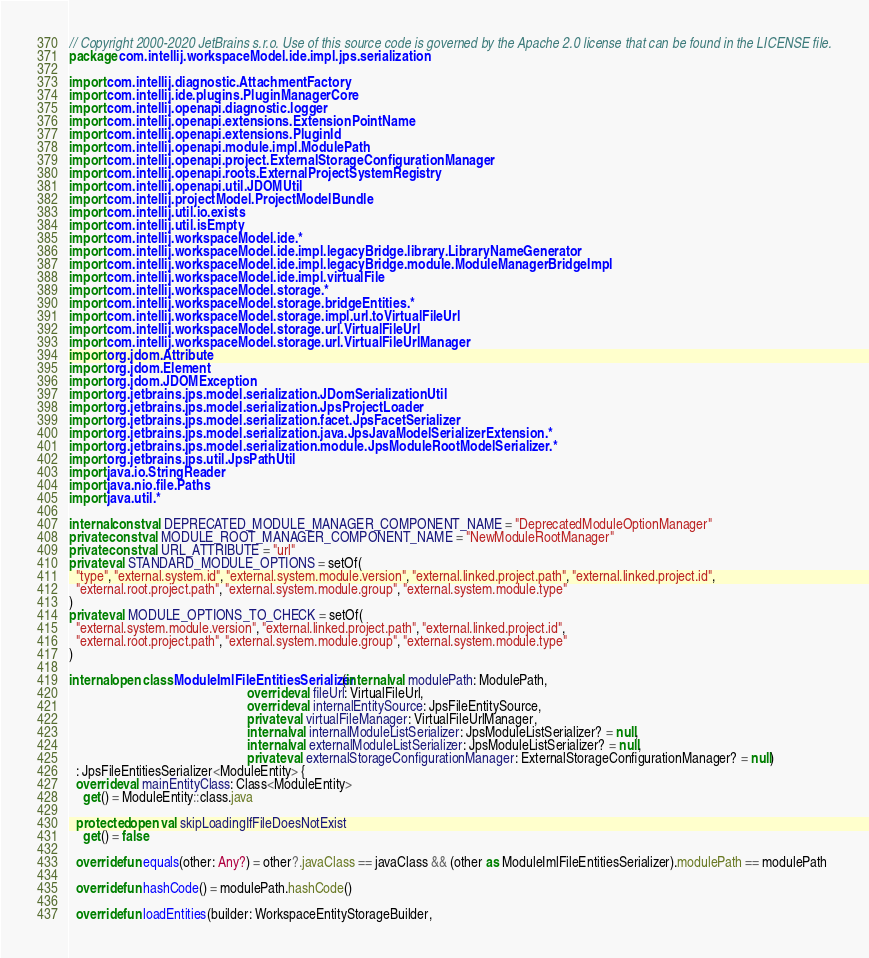Convert code to text. <code><loc_0><loc_0><loc_500><loc_500><_Kotlin_>// Copyright 2000-2020 JetBrains s.r.o. Use of this source code is governed by the Apache 2.0 license that can be found in the LICENSE file.
package com.intellij.workspaceModel.ide.impl.jps.serialization

import com.intellij.diagnostic.AttachmentFactory
import com.intellij.ide.plugins.PluginManagerCore
import com.intellij.openapi.diagnostic.logger
import com.intellij.openapi.extensions.ExtensionPointName
import com.intellij.openapi.extensions.PluginId
import com.intellij.openapi.module.impl.ModulePath
import com.intellij.openapi.project.ExternalStorageConfigurationManager
import com.intellij.openapi.roots.ExternalProjectSystemRegistry
import com.intellij.openapi.util.JDOMUtil
import com.intellij.projectModel.ProjectModelBundle
import com.intellij.util.io.exists
import com.intellij.util.isEmpty
import com.intellij.workspaceModel.ide.*
import com.intellij.workspaceModel.ide.impl.legacyBridge.library.LibraryNameGenerator
import com.intellij.workspaceModel.ide.impl.legacyBridge.module.ModuleManagerBridgeImpl
import com.intellij.workspaceModel.ide.impl.virtualFile
import com.intellij.workspaceModel.storage.*
import com.intellij.workspaceModel.storage.bridgeEntities.*
import com.intellij.workspaceModel.storage.impl.url.toVirtualFileUrl
import com.intellij.workspaceModel.storage.url.VirtualFileUrl
import com.intellij.workspaceModel.storage.url.VirtualFileUrlManager
import org.jdom.Attribute
import org.jdom.Element
import org.jdom.JDOMException
import org.jetbrains.jps.model.serialization.JDomSerializationUtil
import org.jetbrains.jps.model.serialization.JpsProjectLoader
import org.jetbrains.jps.model.serialization.facet.JpsFacetSerializer
import org.jetbrains.jps.model.serialization.java.JpsJavaModelSerializerExtension.*
import org.jetbrains.jps.model.serialization.module.JpsModuleRootModelSerializer.*
import org.jetbrains.jps.util.JpsPathUtil
import java.io.StringReader
import java.nio.file.Paths
import java.util.*

internal const val DEPRECATED_MODULE_MANAGER_COMPONENT_NAME = "DeprecatedModuleOptionManager"
private const val MODULE_ROOT_MANAGER_COMPONENT_NAME = "NewModuleRootManager"
private const val URL_ATTRIBUTE = "url"
private val STANDARD_MODULE_OPTIONS = setOf(
  "type", "external.system.id", "external.system.module.version", "external.linked.project.path", "external.linked.project.id",
  "external.root.project.path", "external.system.module.group", "external.system.module.type"
)
private val MODULE_OPTIONS_TO_CHECK = setOf(
  "external.system.module.version", "external.linked.project.path", "external.linked.project.id",
  "external.root.project.path", "external.system.module.group", "external.system.module.type"
)

internal open class ModuleImlFileEntitiesSerializer(internal val modulePath: ModulePath,
                                                    override val fileUrl: VirtualFileUrl,
                                                    override val internalEntitySource: JpsFileEntitySource,
                                                    private val virtualFileManager: VirtualFileUrlManager,
                                                    internal val internalModuleListSerializer: JpsModuleListSerializer? = null,
                                                    internal val externalModuleListSerializer: JpsModuleListSerializer? = null,
                                                    private val externalStorageConfigurationManager: ExternalStorageConfigurationManager? = null)
  : JpsFileEntitiesSerializer<ModuleEntity> {
  override val mainEntityClass: Class<ModuleEntity>
    get() = ModuleEntity::class.java

  protected open val skipLoadingIfFileDoesNotExist
    get() = false

  override fun equals(other: Any?) = other?.javaClass == javaClass && (other as ModuleImlFileEntitiesSerializer).modulePath == modulePath

  override fun hashCode() = modulePath.hashCode()

  override fun loadEntities(builder: WorkspaceEntityStorageBuilder,</code> 